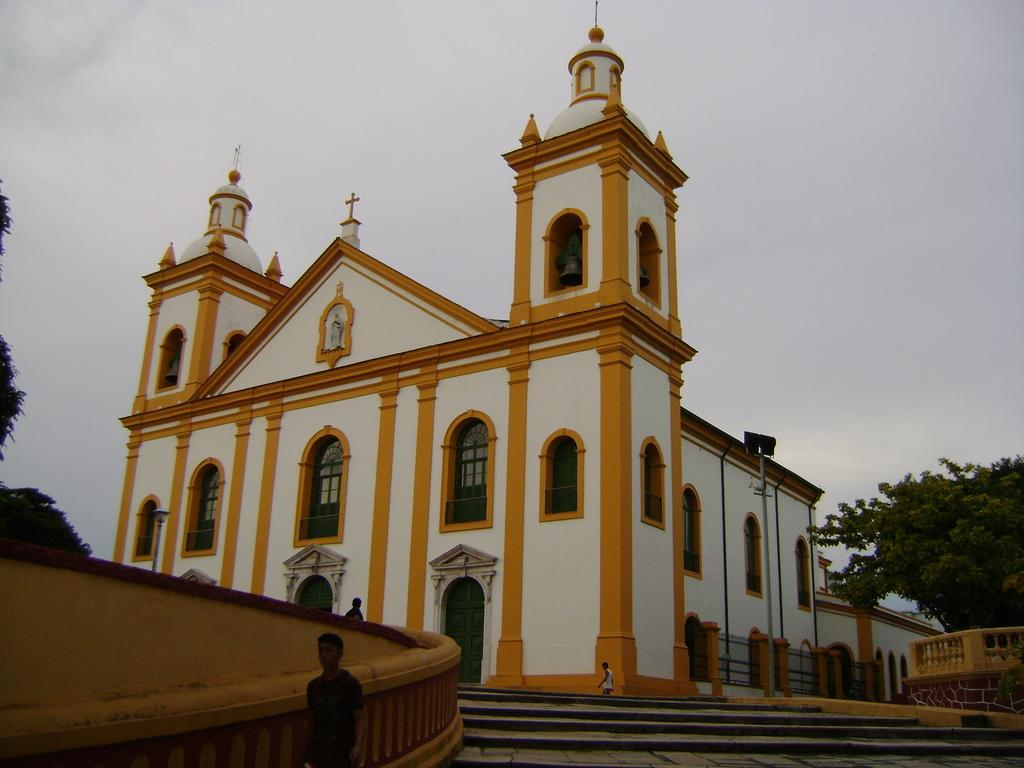What type of structure is present in the image? There is a building in the image. Are there any people in the image? Yes, there are persons in the image. What other natural elements can be seen in the image? There are trees in the image. What can be seen in the background of the image? The sky is visible in the background of the image. What does the earth taste like in the image? The image does not depict the taste of the earth, as it is a visual representation and not a sensory experience. 